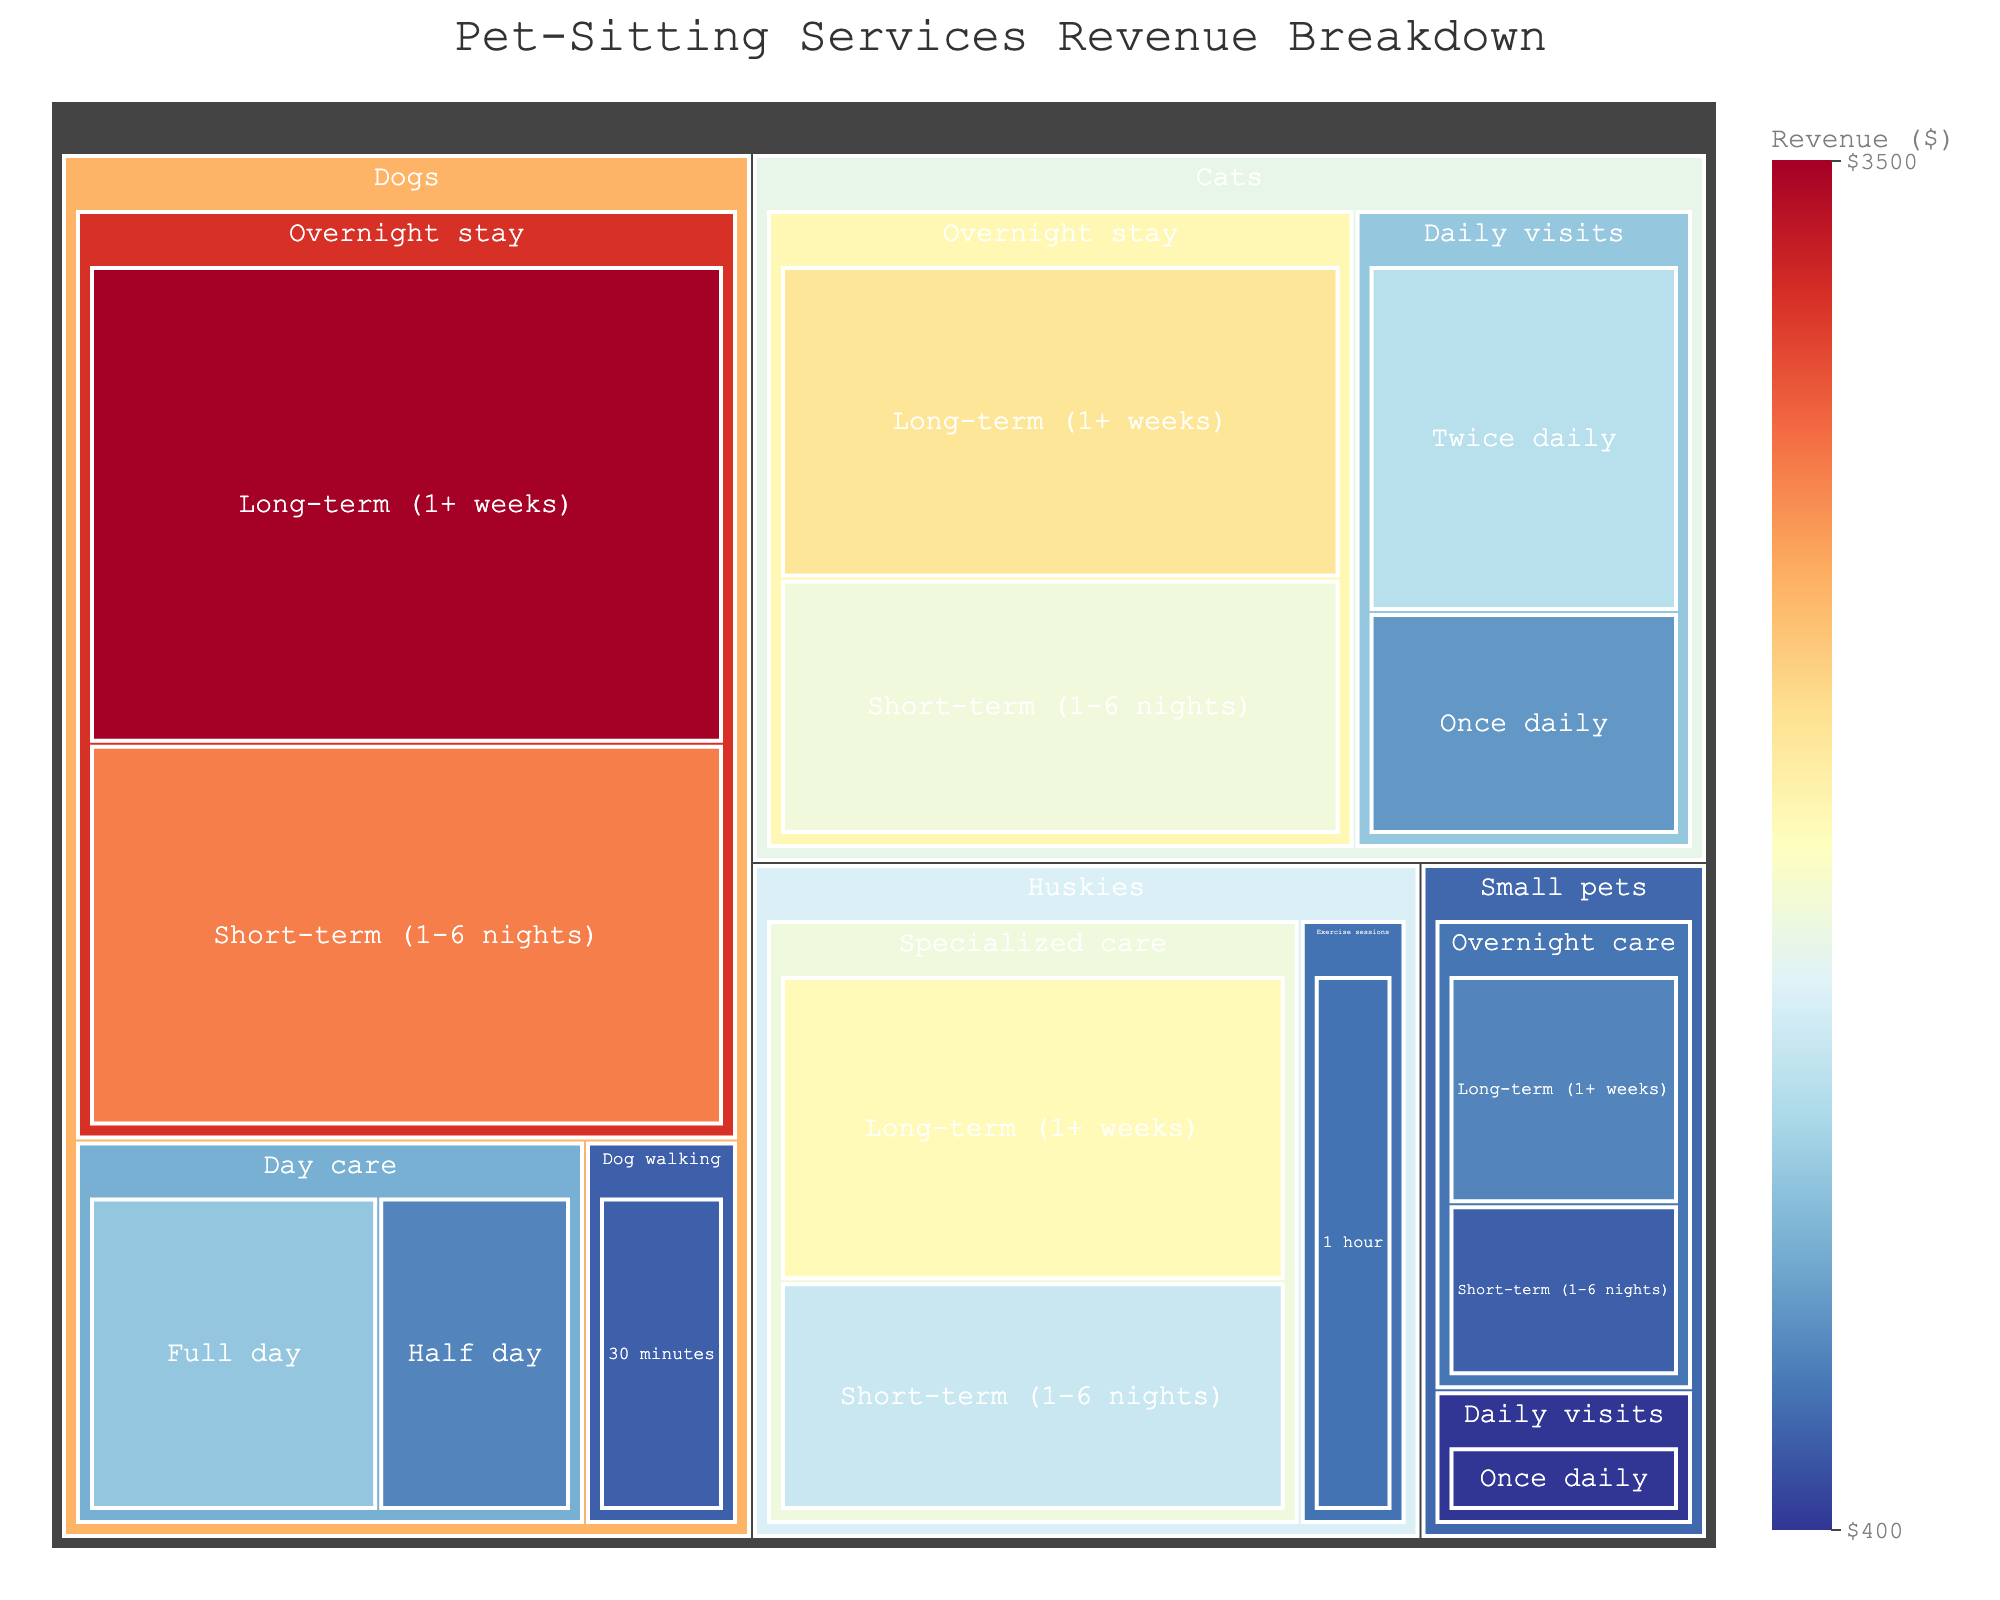How much revenue is generated from overnight stays for dogs? Locate the section for Dogs, then find the sub-section for Overnight stay. Sum the revenues from Long-term and Short-term stays, which are $3500 and $2800 respectively. So, the total revenue is $3500 + $2800.
Answer: $6300 What is the total revenue from all services for Cats? Find all sections for Cats and add up the revenue values: Overnight stay (Long-term $2200, Short-term $1800), Daily visits (Once daily $900, Twice daily $1400). Sum all these values: $2200 + $1800 + $900 + $1400.
Answer: $6300 Which service has the highest revenue for Huskies? In the Huskies section, compare the revenue values for Specialized care (Long-term $2000, Short-term $1500) and Exercise sessions (1 hour $700). The largest value is $2000.
Answer: Specialized care (Long-term) How does the revenue from short-term overnight stays for small pets compare to long-term overnight stays? In the Small pets section, compare the revenue from Short-term overnight care ($600) to Long-term overnight care ($800). The short-term value is less than the long-term value.
Answer: Short-term is less than long-term What is the difference in revenue between short-term and long-term specialized care for Huskies? Find the revenue values for Specialized care for Huskies: Short-term ($1500) and Long-term ($2000). Subtract the short-term value from the long-term value: $2000 - $1500.
Answer: $500 Which animal type generates the highest total revenue? Sum the total revenue for each animal type: Dogs ($3500 + $2800 + $1200 + $800 + $600 = $8900), Cats ($6200), Small pets ($1800), Huskies ($4200). The highest value is for Dogs.
Answer: Dogs What's the combined revenue from all Day care services for Dogs? Add the revenue values from the Day care services for Dogs: Full day ($1200) and Half day ($800). The combined revenue is $1200 + $800.
Answer: $2000 What is the smallest revenue segment on the treemap? Identify the section with the smallest numerical value. The smallest revenue is from Small pets with Daily visits (Once daily) which is $400.
Answer: Small pets, Daily visits (Once daily) What percentage of the total revenue does the short-term overnight stay for dogs represent? Calculate the total revenue first: $8900 + $6200 + $1800 + $4200 = $21100. The revenue from short-term overnight stays for dogs is $2800. The percentage is ($2800 / $21100) * 100%.
Answer: About 13.27% What animal and service combination generates precisely $1400 in revenue? Look for a segment with the exact revenue value of $1400. The Cats section with Daily visits (Twice daily) matches this value.
Answer: Cats, Daily visits (Twice daily) 